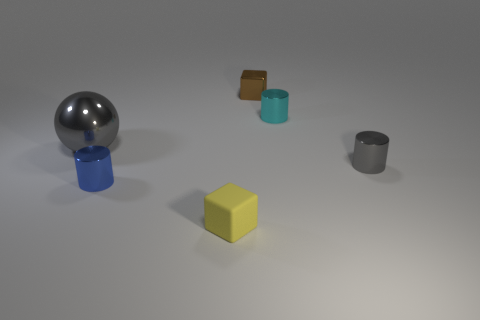Add 1 shiny cylinders. How many objects exist? 7 Subtract all balls. How many objects are left? 5 Add 1 matte things. How many matte things are left? 2 Add 2 tiny rubber spheres. How many tiny rubber spheres exist? 2 Subtract 0 gray cubes. How many objects are left? 6 Subtract all red cubes. Subtract all brown blocks. How many objects are left? 5 